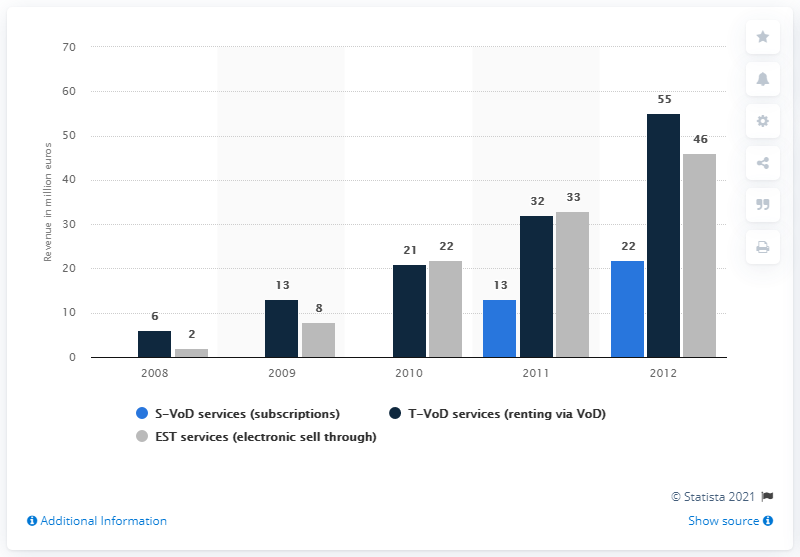Draw attention to some important aspects in this diagram. In 2010, the amount of money generated by T-VoD services in Germany was 21... 